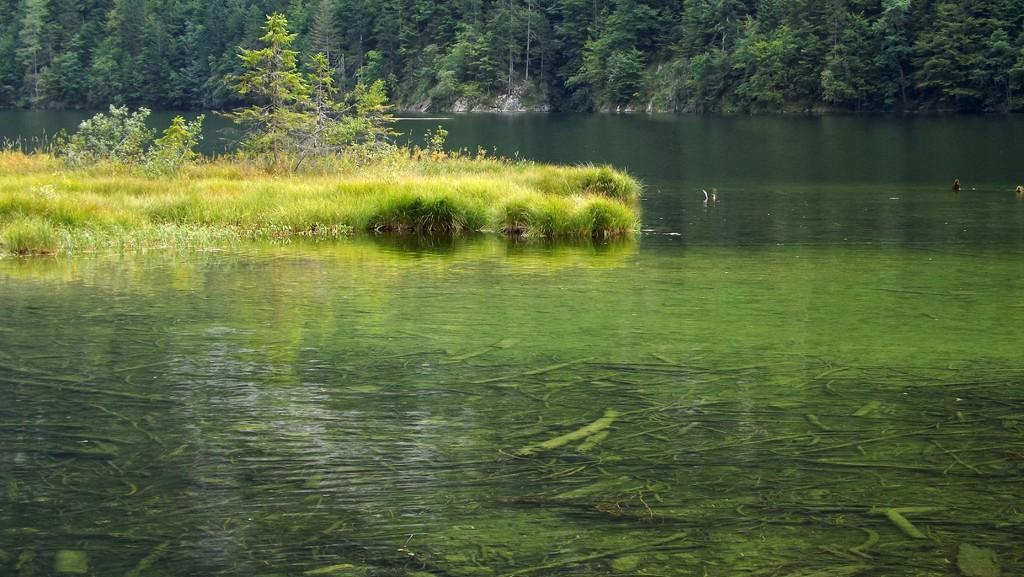Describe this image in one or two sentences. In this image, there is an outside view. There is a grass in the middle of a river. There are some trees at the top of the image. 